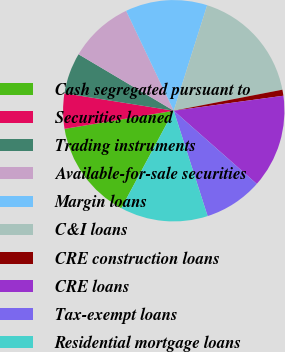Convert chart. <chart><loc_0><loc_0><loc_500><loc_500><pie_chart><fcel>Cash segregated pursuant to<fcel>Securities loaned<fcel>Trading instruments<fcel>Available-for-sale securities<fcel>Margin loans<fcel>C&I loans<fcel>CRE construction loans<fcel>CRE loans<fcel>Tax-exempt loans<fcel>Residential mortgage loans<nl><fcel>14.52%<fcel>5.14%<fcel>6.0%<fcel>9.4%<fcel>11.96%<fcel>17.07%<fcel>0.88%<fcel>13.66%<fcel>8.55%<fcel>12.81%<nl></chart> 